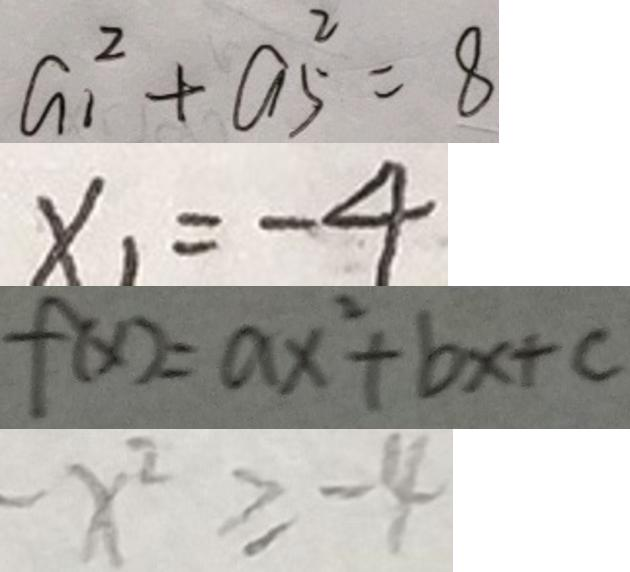Convert formula to latex. <formula><loc_0><loc_0><loc_500><loc_500>a _ { 1 } ^ { 2 } + a _ { 5 } ^ { 2 } = 8 
 x _ { 1 } = - 4 
 f ( x ) = a x ^ { 2 } + b x + c 
 - x ^ { 2 } \geq - 4</formula> 